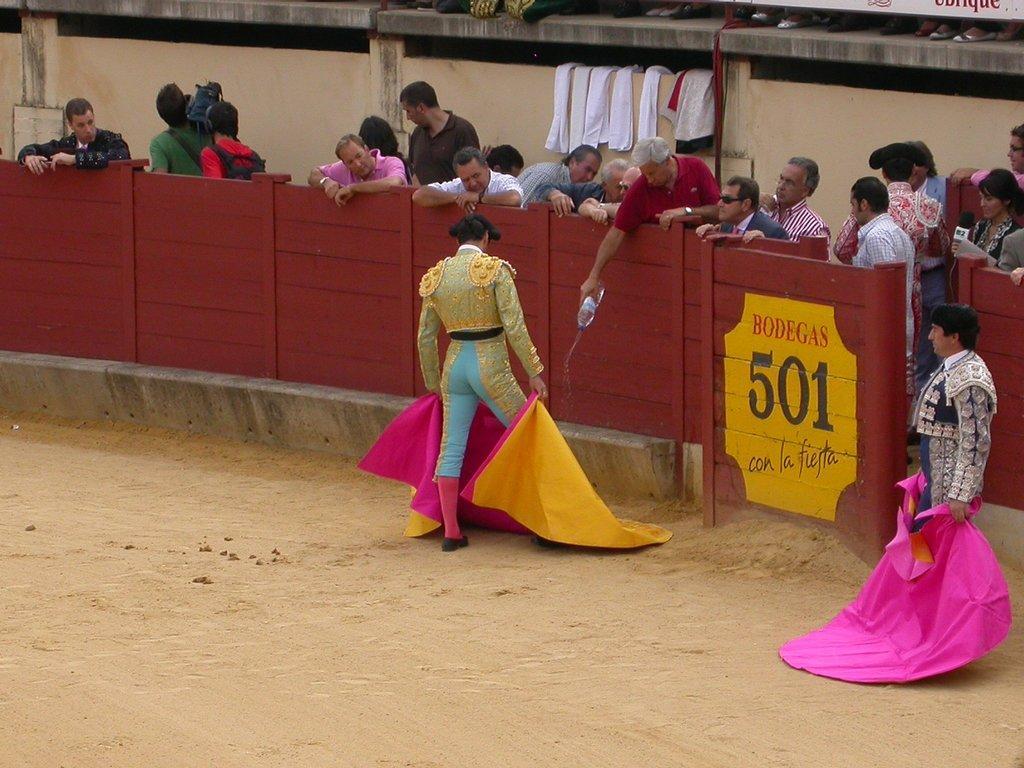Can you describe this image briefly? In this image I can see the ground and two persons standing and holding clothes in their hands. I can see the wooden railing which is brown in color and number of persons standing behind the wooden railing. I can see few clothes on the wall. 